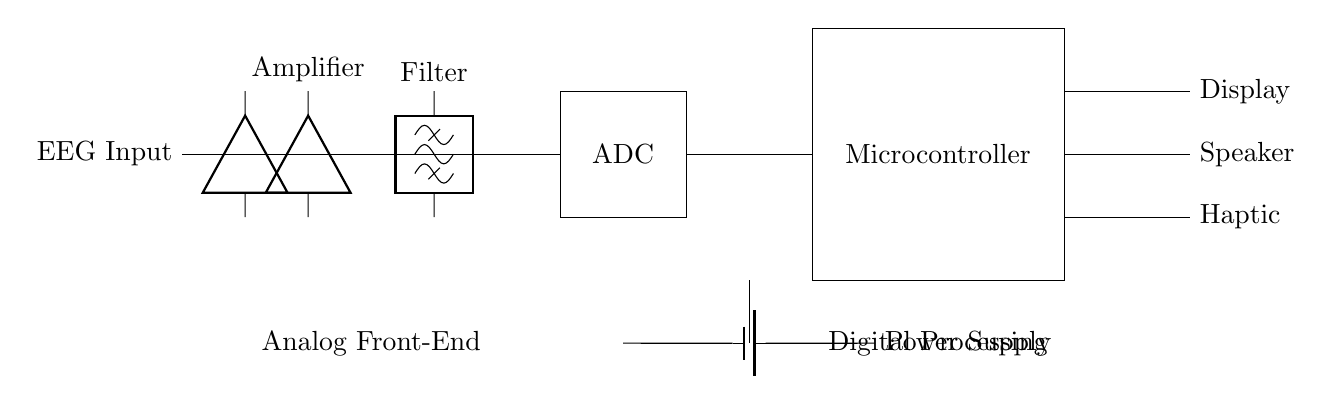What component is connected to the EEG Input? The component connected to the EEG Input is an amplifier. This can be determined by following the circuit from the EEG Input, which goes directly to an amplifier component.
Answer: amplifier What type of filter is used in the circuit? The circuit uses a bandpass filter. This is indicated by the label on the filter component in the circuit diagram.
Answer: bandpass What number of outputs does the microcontroller have? The microcontroller has three outputs. By analyzing the connections from the microcontroller, there are three distinct lines leading to a display, speaker, and haptic output.
Answer: three What is the purpose of the ADC in the circuit? The purpose of the ADC (Analog-to-Digital Converter) is to convert the analog signal from the amplifier/filter into a digital signal for processing. This is inferred from its placement in the circuit immediately after the amplifier and filter, indicating its role in digitizing the processed signals.
Answer: digitizing What is the power supply type used in this circuit? The power supply type in this circuit is a battery. This can be confirmed by the specific symbol used in the circuit diagram which denotes a battery as the power source.
Answer: battery What is the role of the Microcontroller in the circuit? The role of the microcontroller is digital processing. This is understood from its label and position in the circuit, following the ADC, suggesting it processes the digital signals received.
Answer: digital processing 